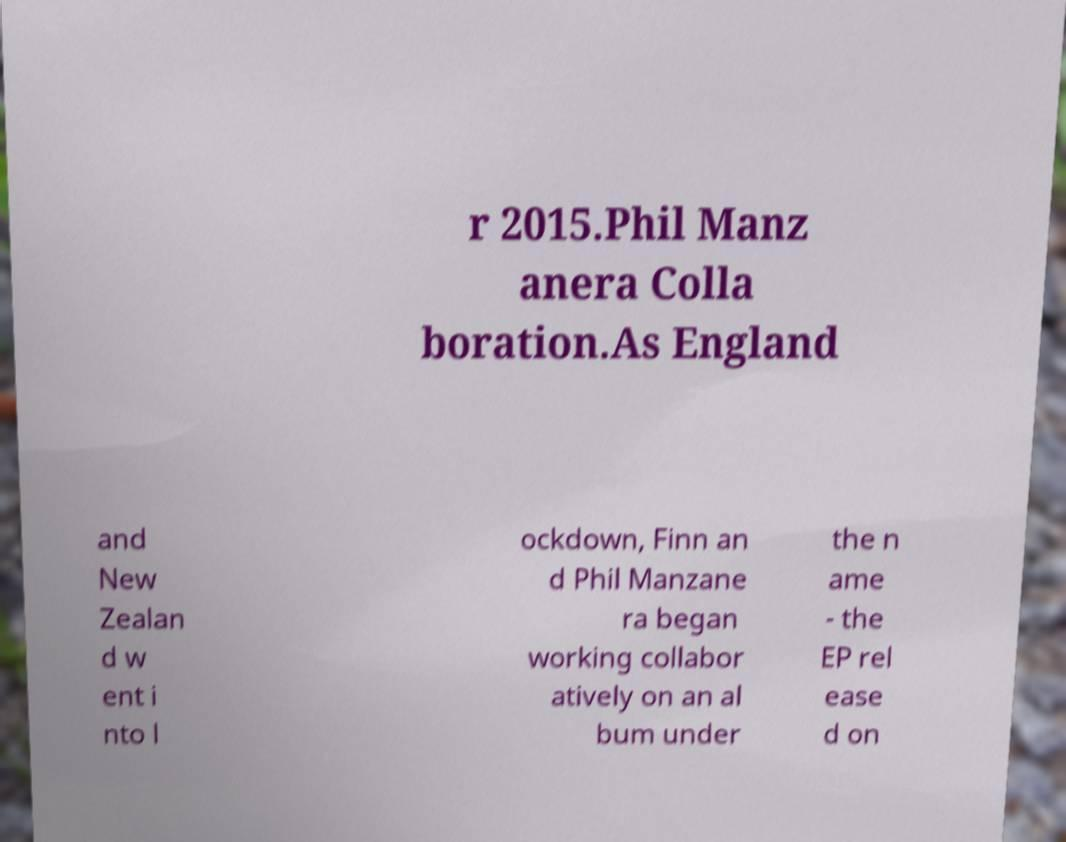Could you extract and type out the text from this image? r 2015.Phil Manz anera Colla boration.As England and New Zealan d w ent i nto l ockdown, Finn an d Phil Manzane ra began working collabor atively on an al bum under the n ame - the EP rel ease d on 